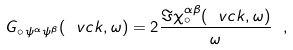<formula> <loc_0><loc_0><loc_500><loc_500>G _ { \circ \, \psi ^ { \alpha } \psi ^ { \beta } } ( { \ v c k } , \omega ) = 2 \frac { \Im \chi _ { \circ } ^ { \alpha \beta } ( { \ v c k } , \omega ) } { \omega } \ ,</formula> 